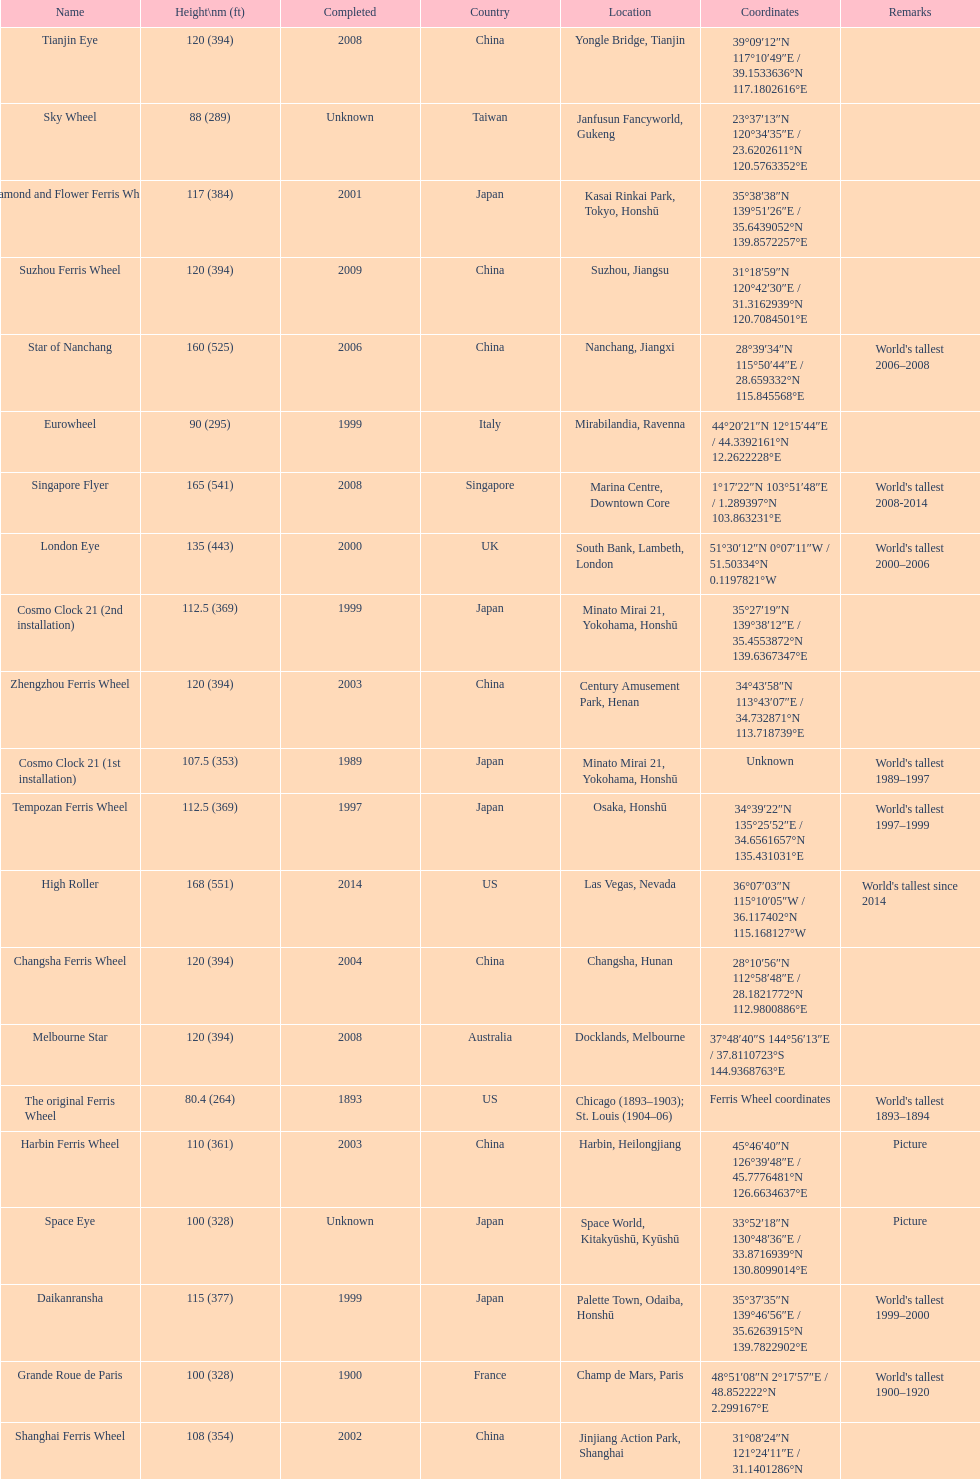Which ferris wheel was completed in 2008 and has the height of 165? Singapore Flyer. 